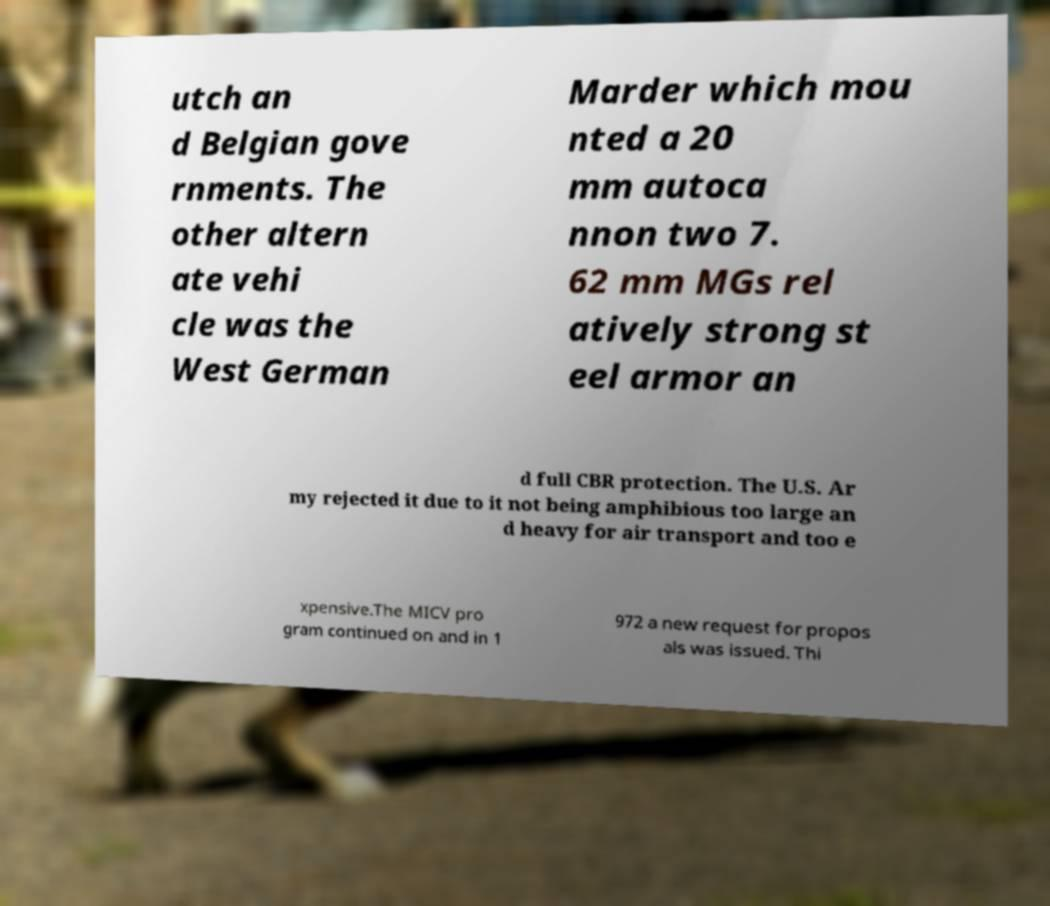For documentation purposes, I need the text within this image transcribed. Could you provide that? utch an d Belgian gove rnments. The other altern ate vehi cle was the West German Marder which mou nted a 20 mm autoca nnon two 7. 62 mm MGs rel atively strong st eel armor an d full CBR protection. The U.S. Ar my rejected it due to it not being amphibious too large an d heavy for air transport and too e xpensive.The MICV pro gram continued on and in 1 972 a new request for propos als was issued. Thi 